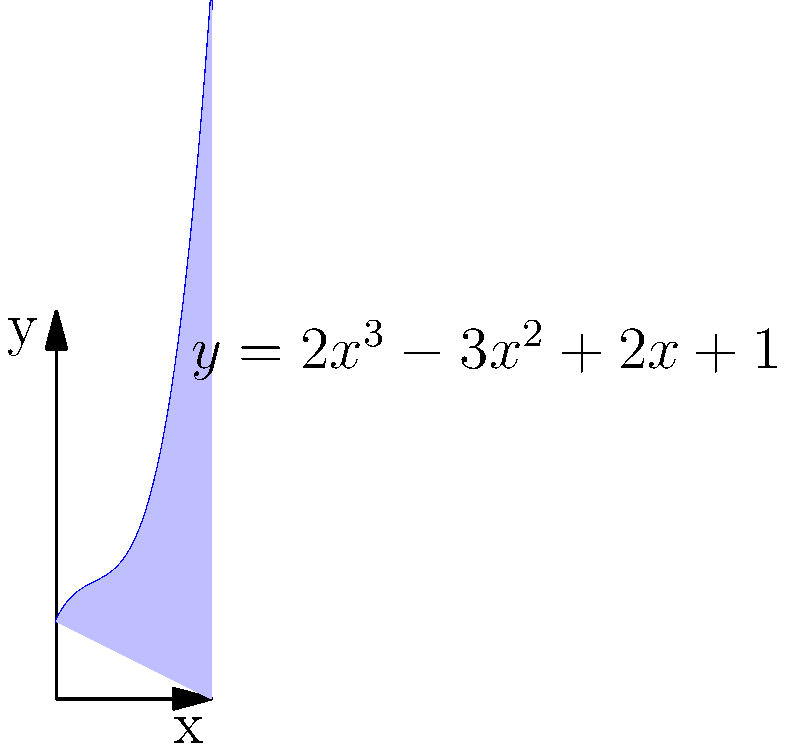As a government official overseeing economic regulations, you need to analyze the economic growth across different sectors. The curve $y = 2x^3 - 3x^2 + 2x + 1$ represents the rate of economic growth (in percentage) for various sectors over a 2-year period, where $x$ represents the time in years. Calculate the total economic growth over this period by finding the area under the curve from $x=0$ to $x=2$. To find the area under the curve, we need to integrate the function from 0 to 2:

1) The integral is: $$\int_0^2 (2x^3 - 3x^2 + 2x + 1) dx$$

2) Integrate each term:
   $$\left[\frac{1}{2}x^4 - x^3 + x^2 + x\right]_0^2$$

3) Evaluate at the upper and lower bounds:
   $$\left(\frac{1}{2}(2^4) - (2^3) + (2^2) + 2\right) - \left(\frac{1}{2}(0^4) - (0^3) + (0^2) + 0\right)$$

4) Simplify:
   $$(8 - 8 + 4 + 2) - (0)$$
   $$= 6 - 0 = 6$$

Therefore, the total economic growth over the 2-year period is 6 percentage-years.
Answer: 6 percentage-years 